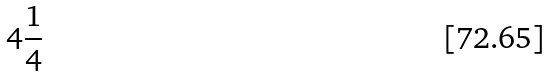<formula> <loc_0><loc_0><loc_500><loc_500>4 \frac { 1 } { 4 }</formula> 